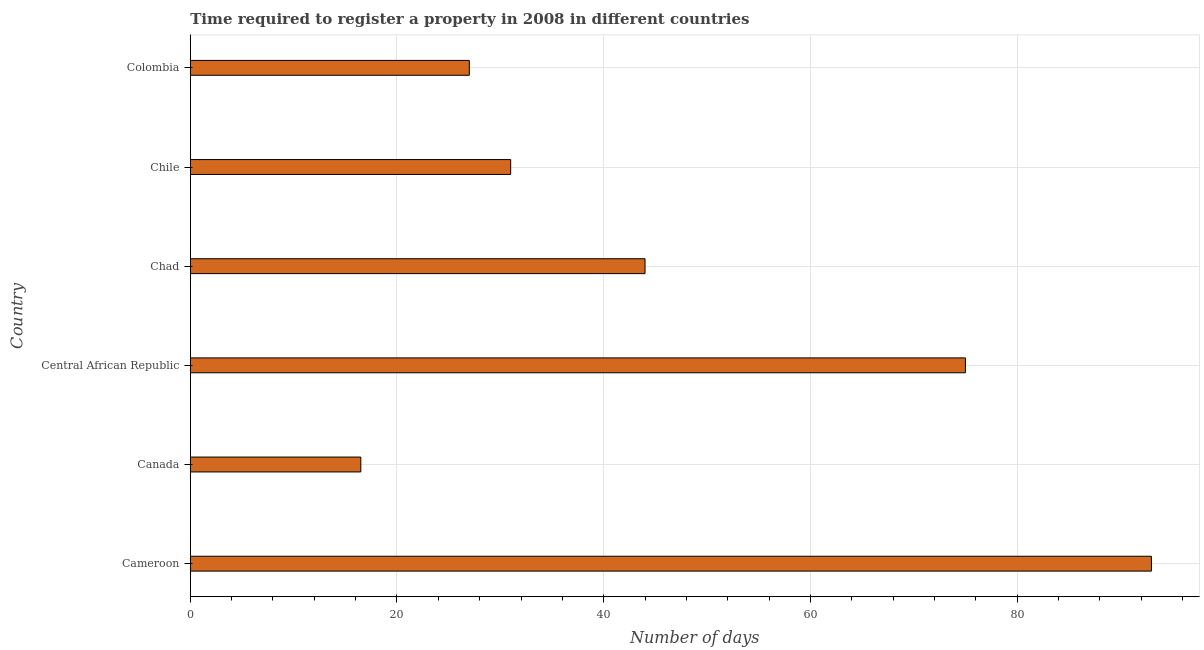Does the graph contain grids?
Offer a terse response. Yes. What is the title of the graph?
Keep it short and to the point. Time required to register a property in 2008 in different countries. What is the label or title of the X-axis?
Keep it short and to the point. Number of days. What is the label or title of the Y-axis?
Provide a short and direct response. Country. What is the number of days required to register property in Cameroon?
Keep it short and to the point. 93. Across all countries, what is the maximum number of days required to register property?
Ensure brevity in your answer.  93. In which country was the number of days required to register property maximum?
Your answer should be compact. Cameroon. What is the sum of the number of days required to register property?
Give a very brief answer. 286.5. What is the difference between the number of days required to register property in Chad and Chile?
Offer a terse response. 13. What is the average number of days required to register property per country?
Make the answer very short. 47.75. What is the median number of days required to register property?
Your answer should be compact. 37.5. In how many countries, is the number of days required to register property greater than 88 days?
Offer a terse response. 1. What is the ratio of the number of days required to register property in Cameroon to that in Canada?
Offer a terse response. 5.64. Is the number of days required to register property in Canada less than that in Chad?
Keep it short and to the point. Yes. Is the difference between the number of days required to register property in Cameroon and Chile greater than the difference between any two countries?
Give a very brief answer. No. What is the difference between the highest and the second highest number of days required to register property?
Your answer should be compact. 18. What is the difference between the highest and the lowest number of days required to register property?
Make the answer very short. 76.5. Are all the bars in the graph horizontal?
Make the answer very short. Yes. Are the values on the major ticks of X-axis written in scientific E-notation?
Your answer should be compact. No. What is the Number of days of Cameroon?
Your answer should be compact. 93. What is the Number of days in Canada?
Your answer should be compact. 16.5. What is the Number of days of Central African Republic?
Make the answer very short. 75. What is the Number of days of Chad?
Offer a terse response. 44. What is the difference between the Number of days in Cameroon and Canada?
Ensure brevity in your answer.  76.5. What is the difference between the Number of days in Cameroon and Chad?
Offer a very short reply. 49. What is the difference between the Number of days in Cameroon and Colombia?
Make the answer very short. 66. What is the difference between the Number of days in Canada and Central African Republic?
Your response must be concise. -58.5. What is the difference between the Number of days in Canada and Chad?
Offer a terse response. -27.5. What is the difference between the Number of days in Canada and Colombia?
Provide a succinct answer. -10.5. What is the difference between the Number of days in Central African Republic and Chad?
Provide a short and direct response. 31. What is the difference between the Number of days in Central African Republic and Chile?
Provide a succinct answer. 44. What is the difference between the Number of days in Chad and Chile?
Ensure brevity in your answer.  13. What is the difference between the Number of days in Chad and Colombia?
Ensure brevity in your answer.  17. What is the ratio of the Number of days in Cameroon to that in Canada?
Provide a succinct answer. 5.64. What is the ratio of the Number of days in Cameroon to that in Central African Republic?
Offer a terse response. 1.24. What is the ratio of the Number of days in Cameroon to that in Chad?
Your answer should be very brief. 2.11. What is the ratio of the Number of days in Cameroon to that in Chile?
Your answer should be compact. 3. What is the ratio of the Number of days in Cameroon to that in Colombia?
Provide a short and direct response. 3.44. What is the ratio of the Number of days in Canada to that in Central African Republic?
Offer a very short reply. 0.22. What is the ratio of the Number of days in Canada to that in Chad?
Provide a short and direct response. 0.38. What is the ratio of the Number of days in Canada to that in Chile?
Offer a very short reply. 0.53. What is the ratio of the Number of days in Canada to that in Colombia?
Give a very brief answer. 0.61. What is the ratio of the Number of days in Central African Republic to that in Chad?
Keep it short and to the point. 1.71. What is the ratio of the Number of days in Central African Republic to that in Chile?
Your answer should be compact. 2.42. What is the ratio of the Number of days in Central African Republic to that in Colombia?
Give a very brief answer. 2.78. What is the ratio of the Number of days in Chad to that in Chile?
Give a very brief answer. 1.42. What is the ratio of the Number of days in Chad to that in Colombia?
Your answer should be very brief. 1.63. What is the ratio of the Number of days in Chile to that in Colombia?
Your answer should be very brief. 1.15. 